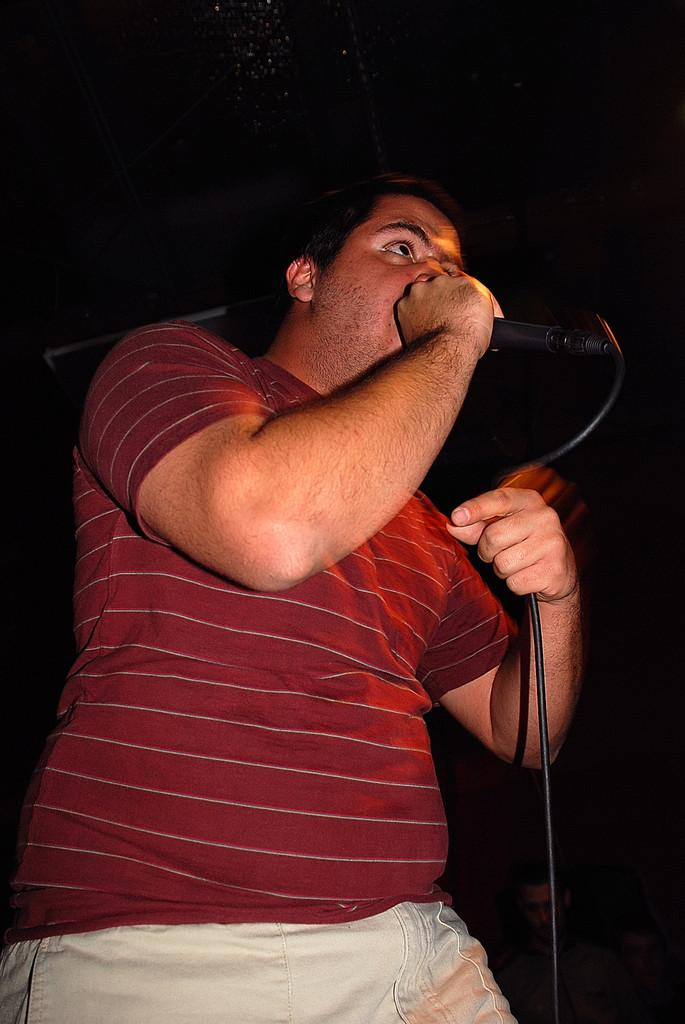Who is present in the image? There is a man in the image. What is the man wearing? The man is wearing a red shirt and cream pants. What is the man holding in his right hand? The man is holding a mic in his right hand. What flavor of cow can be seen in the image? There is no cow present in the image, and therefore no flavor can be determined. 